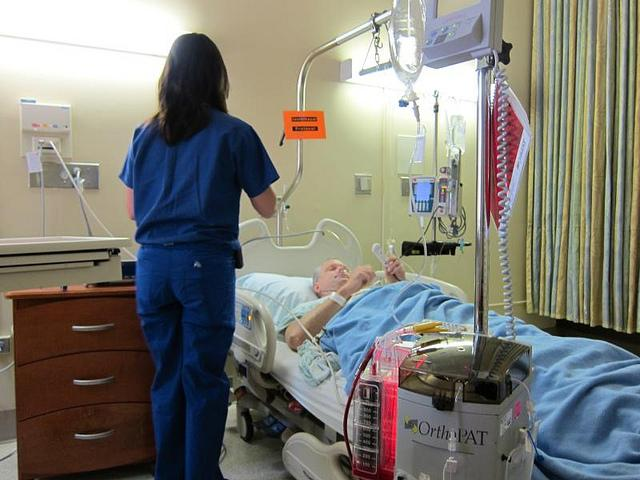Where is the man laying? Please explain your reasoning. hospital bed. When we are very sick we normally have to go to a hospital.  in most cases we have to lay on a hospital bed which is surrounded by medical equipment and personnel. 